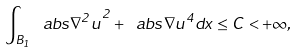Convert formula to latex. <formula><loc_0><loc_0><loc_500><loc_500>\int _ { B _ { 1 } } \ a b s { \nabla ^ { 2 } u } ^ { 2 } + \ a b s { \nabla u } ^ { 4 } d x \leq C < + \infty ,</formula> 